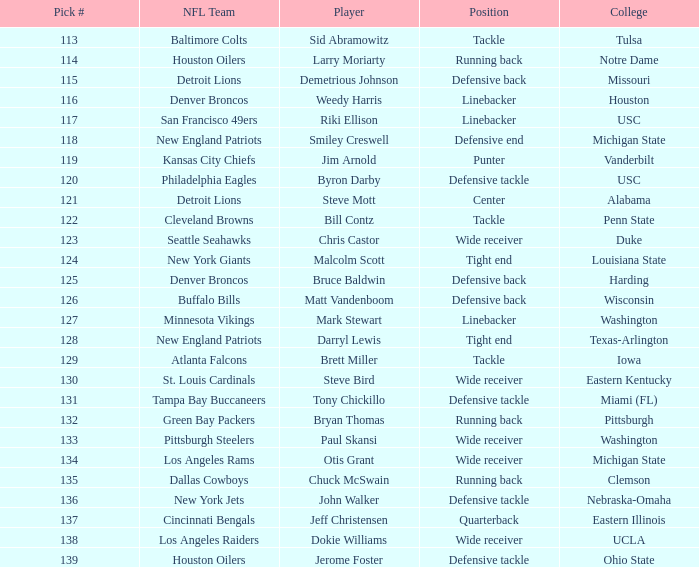Which player did the green bay packers pick? Bryan Thomas. 